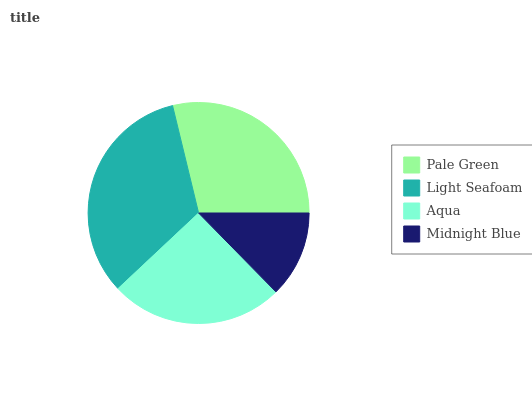Is Midnight Blue the minimum?
Answer yes or no. Yes. Is Light Seafoam the maximum?
Answer yes or no. Yes. Is Aqua the minimum?
Answer yes or no. No. Is Aqua the maximum?
Answer yes or no. No. Is Light Seafoam greater than Aqua?
Answer yes or no. Yes. Is Aqua less than Light Seafoam?
Answer yes or no. Yes. Is Aqua greater than Light Seafoam?
Answer yes or no. No. Is Light Seafoam less than Aqua?
Answer yes or no. No. Is Pale Green the high median?
Answer yes or no. Yes. Is Aqua the low median?
Answer yes or no. Yes. Is Midnight Blue the high median?
Answer yes or no. No. Is Midnight Blue the low median?
Answer yes or no. No. 